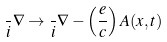<formula> <loc_0><loc_0><loc_500><loc_500>\frac { } { i } \nabla \rightarrow \frac { } { i } \nabla - \left ( \frac { e } { c } \right ) { A } ( { x } , t )</formula> 